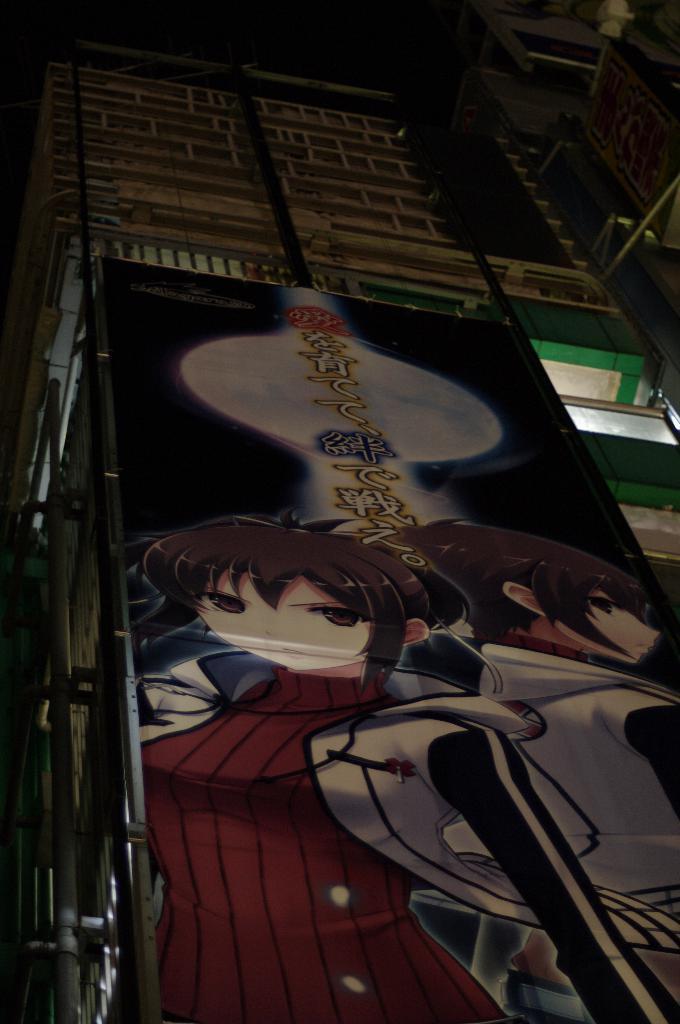Describe this image in one or two sentences. This looks like a poster, which is attached to the building. I think this is a window with a glass door. These look like the pipes, which are attached to the building wall. 